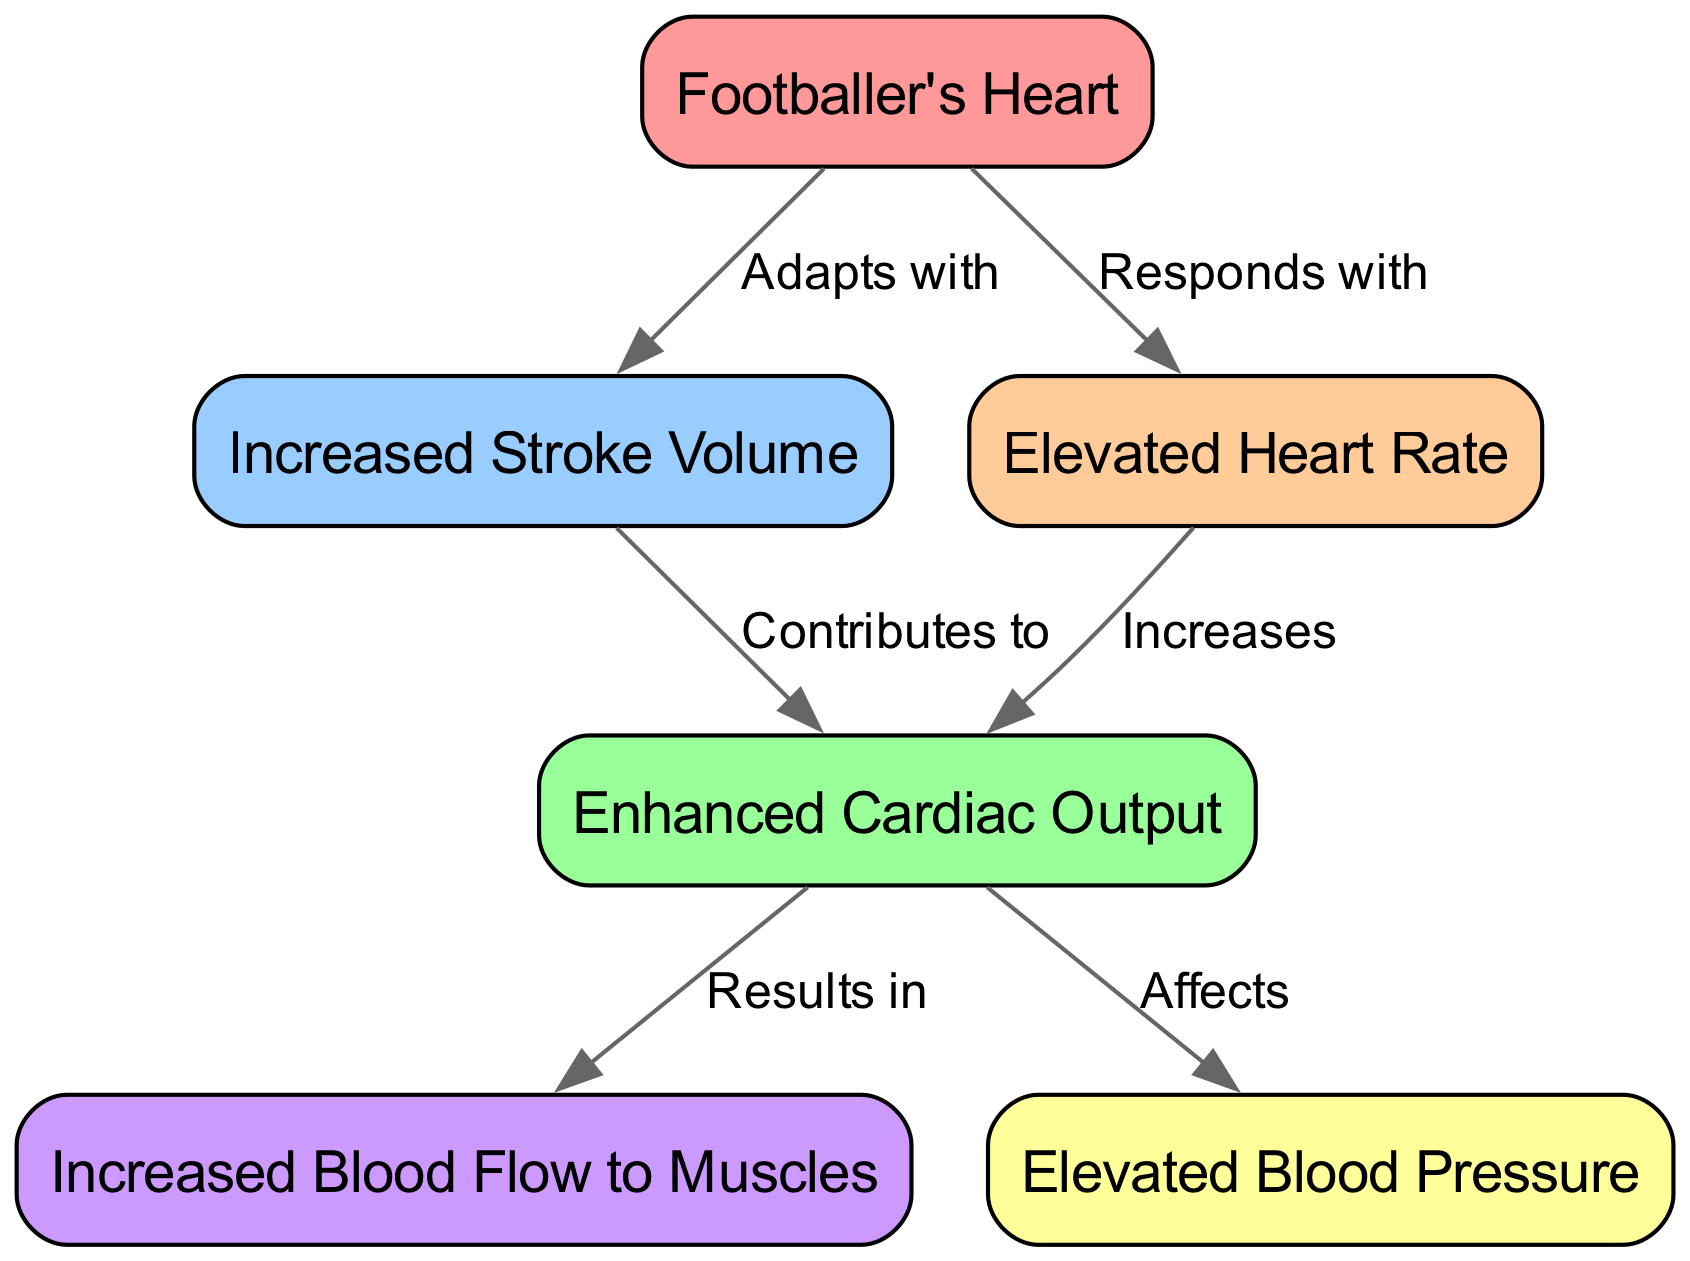What is the heart's adaptation in the diagram? The diagram indicates that the heart adapts by increasing the stroke volume, as shown by the edge connecting "heart" to "stroke_volume" labeled "Adapts with".
Answer: Increased Stroke Volume What does an elevated heart rate respond to? The diagram illustrates that an elevated heart rate responds to the heart, indicated by the edge from "heart" to "heart_rate" labeled "Responds with".
Answer: Heart How many nodes are present in the diagram? By counting all unique nodes listed, there are six nodes: heart, stroke_volume, heart_rate, cardiac_output, blood_flow, and blood_pressure.
Answer: 6 What does increased stroke volume contribute to? The diagram shows that increased stroke volume contributes to enhanced cardiac output, evidenced by the edge labeled "Contributes to" from "stroke_volume" to "cardiac_output".
Answer: Enhanced Cardiac Output How is cardiac output affected by heart rate? The diagram indicates that cardiac output is increased by the heart rate, as represented by the edge labeled "Increases" from "heart_rate" to "cardiac_output".
Answer: Increases What results from enhanced cardiac output? According to the diagram, enhanced cardiac output results in increased blood flow to muscles, illustrated by the connection labeled "Results in" from "cardiac_output" to "blood_flow".
Answer: Increased Blood Flow to Muscles What is affected by cardiac output according to the diagram? The diagram demonstrates that cardiac output affects blood pressure, represented by the edge labeled "Affects" from "cardiac_output" to "blood_pressure".
Answer: Elevated Blood Pressure Which two elements are connected directly to the heart in the diagram? In the diagram, the heart is directly connected to increased stroke volume and elevated heart rate, visible by both edges stemming from the "heart" node.
Answer: Increased Stroke Volume and Elevated Heart Rate What relationship can be identified between cardiac output and blood flow? The diagram shows that there is a direct result relationship where enhanced cardiac output results in increased blood flow to muscles, described by an edge labeled "Results in".
Answer: Results in 